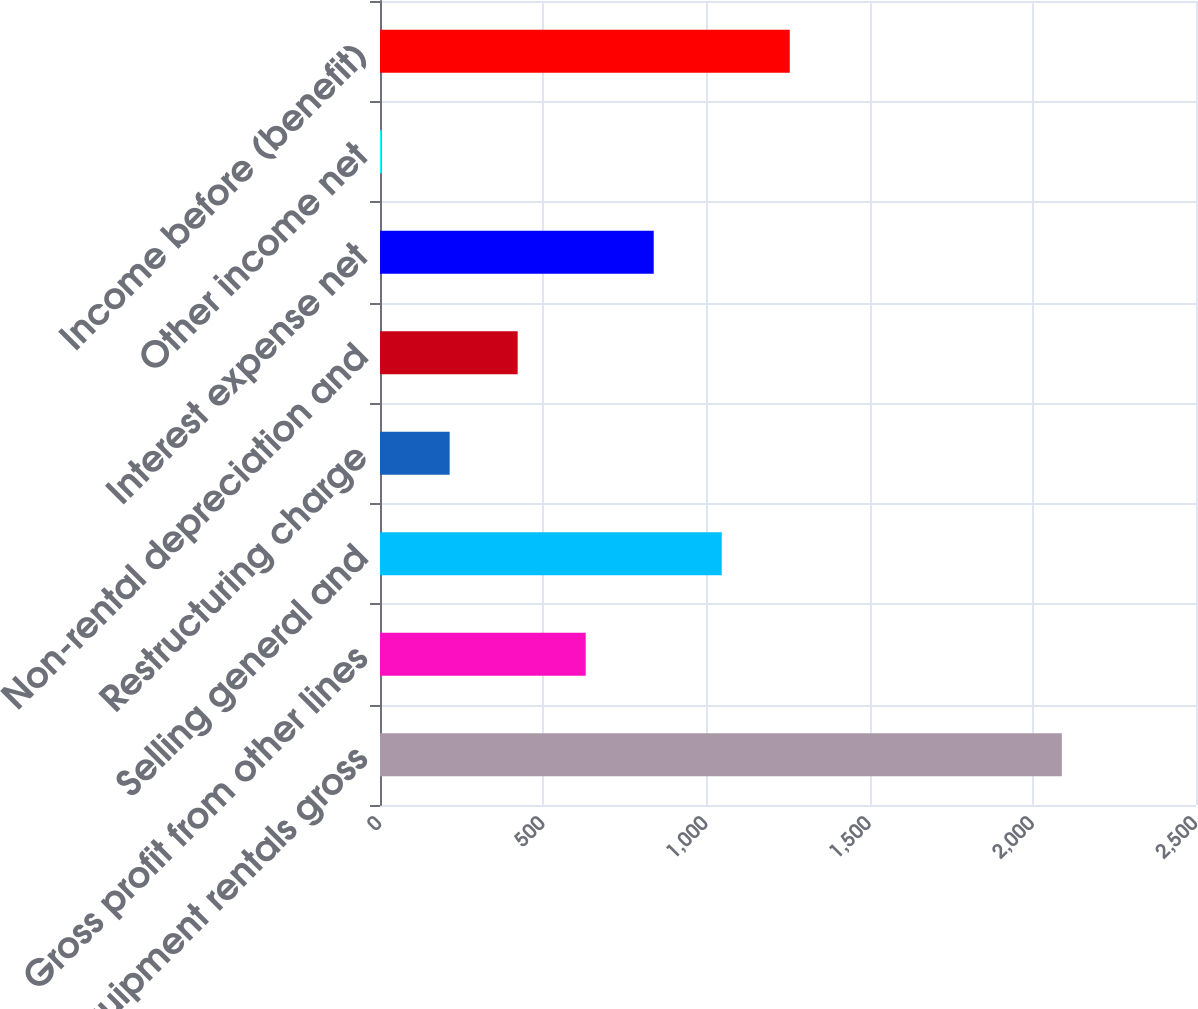<chart> <loc_0><loc_0><loc_500><loc_500><bar_chart><fcel>Total equipment rentals gross<fcel>Gross profit from other lines<fcel>Selling general and<fcel>Restructuring charge<fcel>Non-rental depreciation and<fcel>Interest expense net<fcel>Other income net<fcel>Income before (benefit)<nl><fcel>2089<fcel>630.2<fcel>1047<fcel>213.4<fcel>421.8<fcel>838.6<fcel>5<fcel>1255.4<nl></chart> 